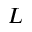<formula> <loc_0><loc_0><loc_500><loc_500>L</formula> 